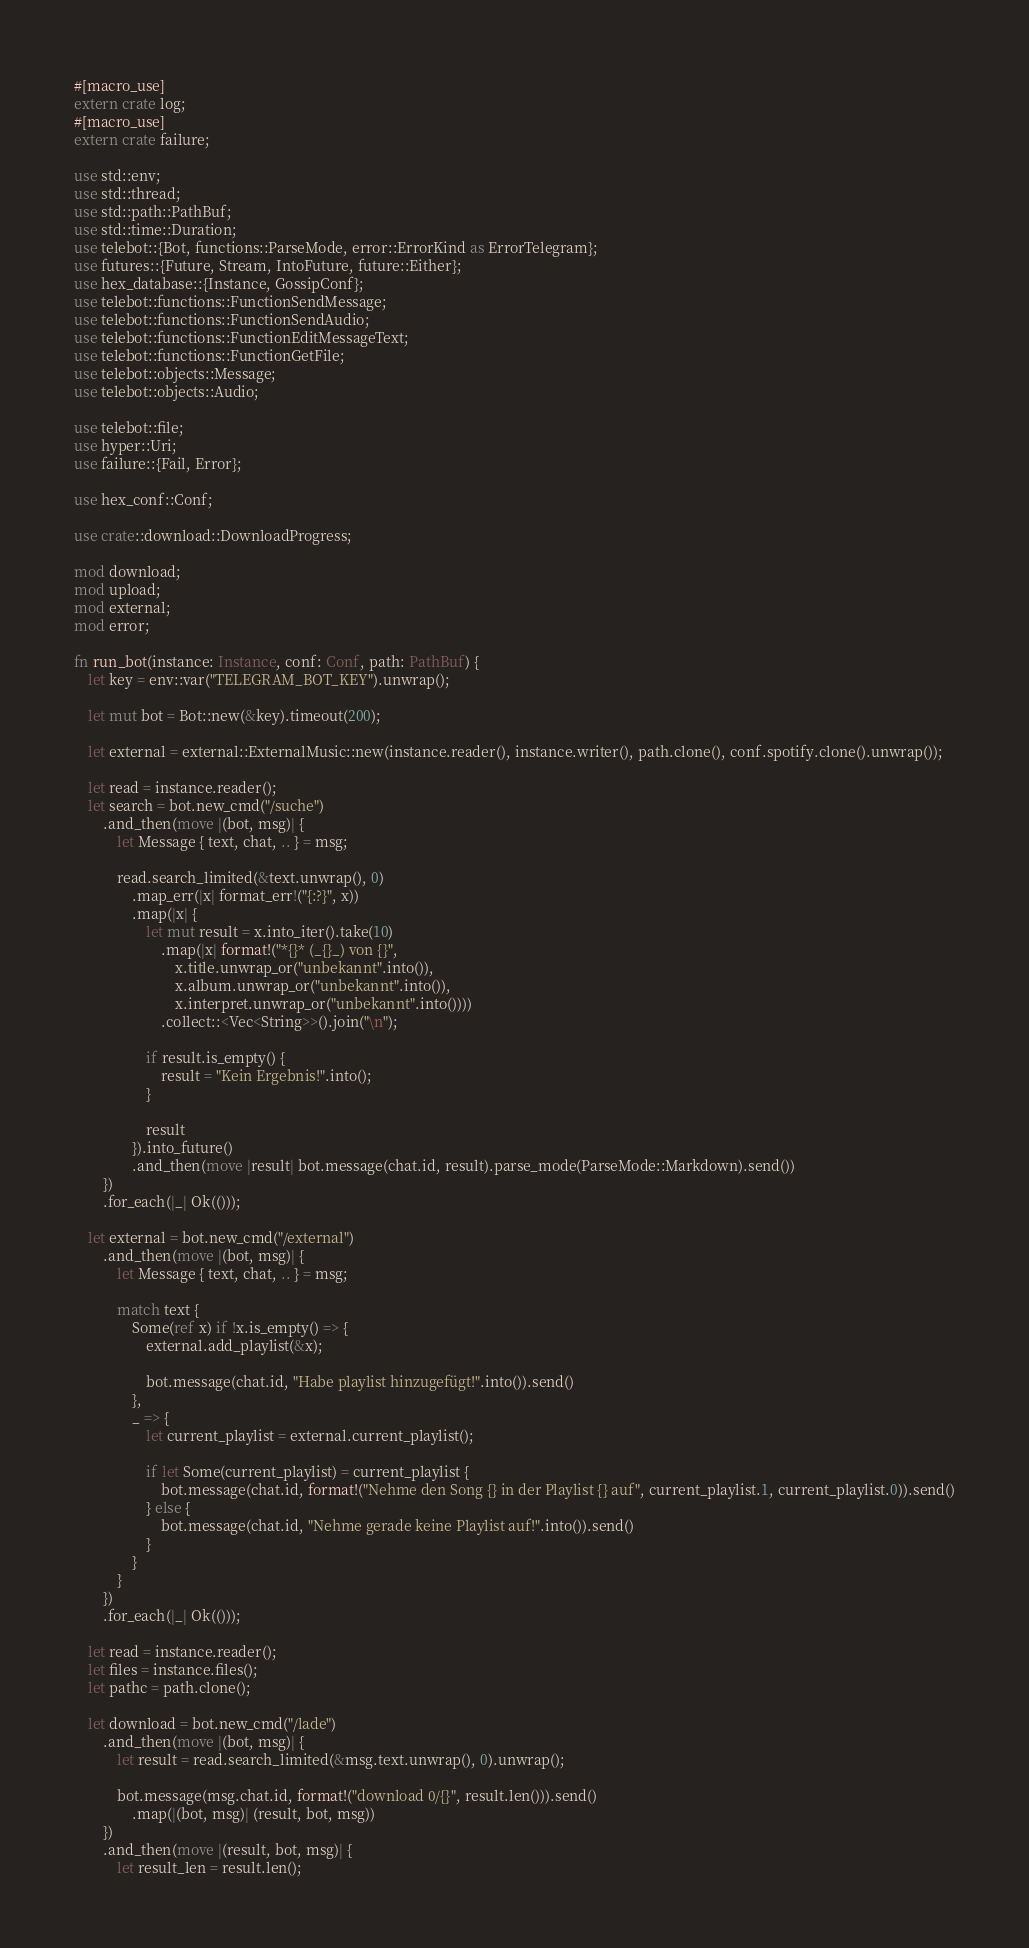<code> <loc_0><loc_0><loc_500><loc_500><_Rust_>#[macro_use]
extern crate log;
#[macro_use]
extern crate failure;

use std::env;
use std::thread;
use std::path::PathBuf;
use std::time::Duration;
use telebot::{Bot, functions::ParseMode, error::ErrorKind as ErrorTelegram};
use futures::{Future, Stream, IntoFuture, future::Either};
use hex_database::{Instance, GossipConf};
use telebot::functions::FunctionSendMessage;
use telebot::functions::FunctionSendAudio;
use telebot::functions::FunctionEditMessageText;
use telebot::functions::FunctionGetFile;
use telebot::objects::Message;
use telebot::objects::Audio;

use telebot::file;
use hyper::Uri;
use failure::{Fail, Error};

use hex_conf::Conf;

use crate::download::DownloadProgress;

mod download;
mod upload;
mod external;
mod error;

fn run_bot(instance: Instance, conf: Conf, path: PathBuf) {
    let key = env::var("TELEGRAM_BOT_KEY").unwrap();

    let mut bot = Bot::new(&key).timeout(200);

    let external = external::ExternalMusic::new(instance.reader(), instance.writer(), path.clone(), conf.spotify.clone().unwrap());

    let read = instance.reader();
    let search = bot.new_cmd("/suche")
        .and_then(move |(bot, msg)| {
            let Message { text, chat, .. } = msg;       

            read.search_limited(&text.unwrap(), 0)
                .map_err(|x| format_err!("{:?}", x))
                .map(|x| {
                    let mut result = x.into_iter().take(10)
                        .map(|x| format!("*{}* (_{}_) von {}", 
                            x.title.unwrap_or("unbekannt".into()), 
                            x.album.unwrap_or("unbekannt".into()), 
                            x.interpret.unwrap_or("unbekannt".into())))
                        .collect::<Vec<String>>().join("\n");

                    if result.is_empty() {
                        result = "Kein Ergebnis!".into();
                    }

                    result
                }).into_future()
                .and_then(move |result| bot.message(chat.id, result).parse_mode(ParseMode::Markdown).send())
        })
        .for_each(|_| Ok(()));

    let external = bot.new_cmd("/external")
        .and_then(move |(bot, msg)| {
            let Message { text, chat, .. } = msg;

            match text {
                Some(ref x) if !x.is_empty() => {
                    external.add_playlist(&x);

                    bot.message(chat.id, "Habe playlist hinzugefügt!".into()).send()
                },
                _ => {
                    let current_playlist = external.current_playlist();

                    if let Some(current_playlist) = current_playlist {
                        bot.message(chat.id, format!("Nehme den Song {} in der Playlist {} auf", current_playlist.1, current_playlist.0)).send()
                    } else {
                        bot.message(chat.id, "Nehme gerade keine Playlist auf!".into()).send()
                    }
                }
            }
        })
        .for_each(|_| Ok(()));

    let read = instance.reader();
    let files = instance.files();
    let pathc = path.clone();

    let download = bot.new_cmd("/lade")
        .and_then(move |(bot, msg)| {
            let result = read.search_limited(&msg.text.unwrap(), 0).unwrap();

            bot.message(msg.chat.id, format!("download 0/{}", result.len())).send()
                .map(|(bot, msg)| (result, bot, msg))
        })
        .and_then(move |(result, bot, msg)| {
            let result_len = result.len();</code> 